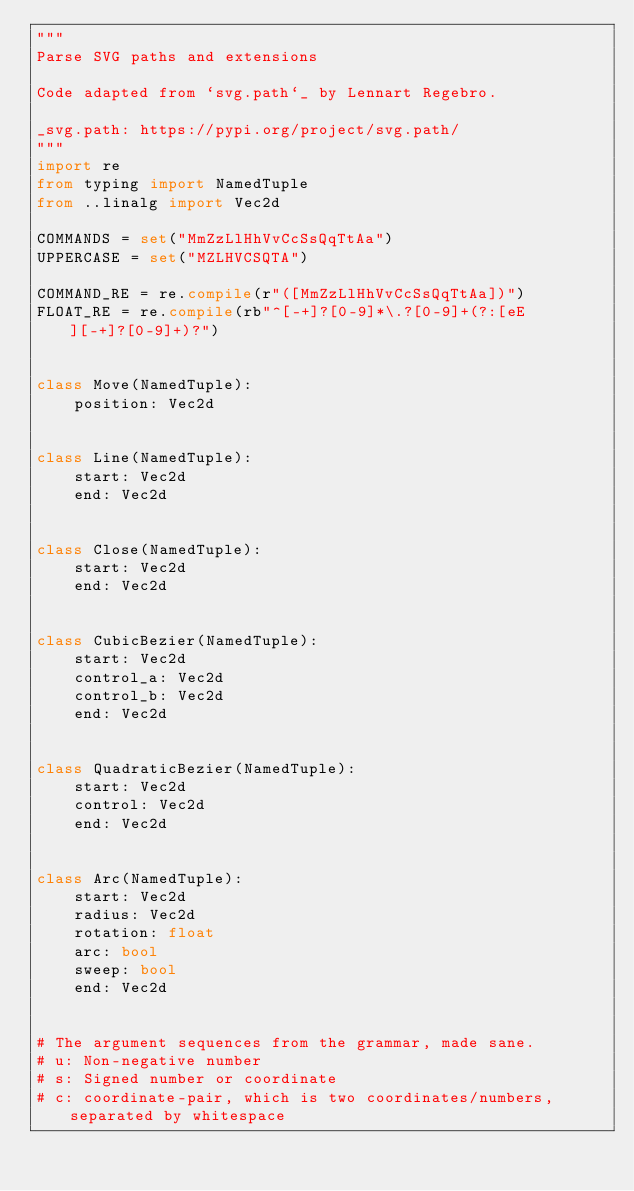Convert code to text. <code><loc_0><loc_0><loc_500><loc_500><_Python_>"""
Parse SVG paths and extensions

Code adapted from `svg.path`_ by Lennart Regebro.

_svg.path: https://pypi.org/project/svg.path/
"""
import re
from typing import NamedTuple
from ..linalg import Vec2d

COMMANDS = set("MmZzLlHhVvCcSsQqTtAa")
UPPERCASE = set("MZLHVCSQTA")

COMMAND_RE = re.compile(r"([MmZzLlHhVvCcSsQqTtAa])")
FLOAT_RE = re.compile(rb"^[-+]?[0-9]*\.?[0-9]+(?:[eE][-+]?[0-9]+)?")


class Move(NamedTuple):
    position: Vec2d


class Line(NamedTuple):
    start: Vec2d
    end: Vec2d


class Close(NamedTuple):
    start: Vec2d
    end: Vec2d


class CubicBezier(NamedTuple):
    start: Vec2d
    control_a: Vec2d
    control_b: Vec2d
    end: Vec2d


class QuadraticBezier(NamedTuple):
    start: Vec2d
    control: Vec2d
    end: Vec2d


class Arc(NamedTuple):
    start: Vec2d
    radius: Vec2d
    rotation: float
    arc: bool
    sweep: bool
    end: Vec2d


# The argument sequences from the grammar, made sane.
# u: Non-negative number
# s: Signed number or coordinate
# c: coordinate-pair, which is two coordinates/numbers, separated by whitespace</code> 